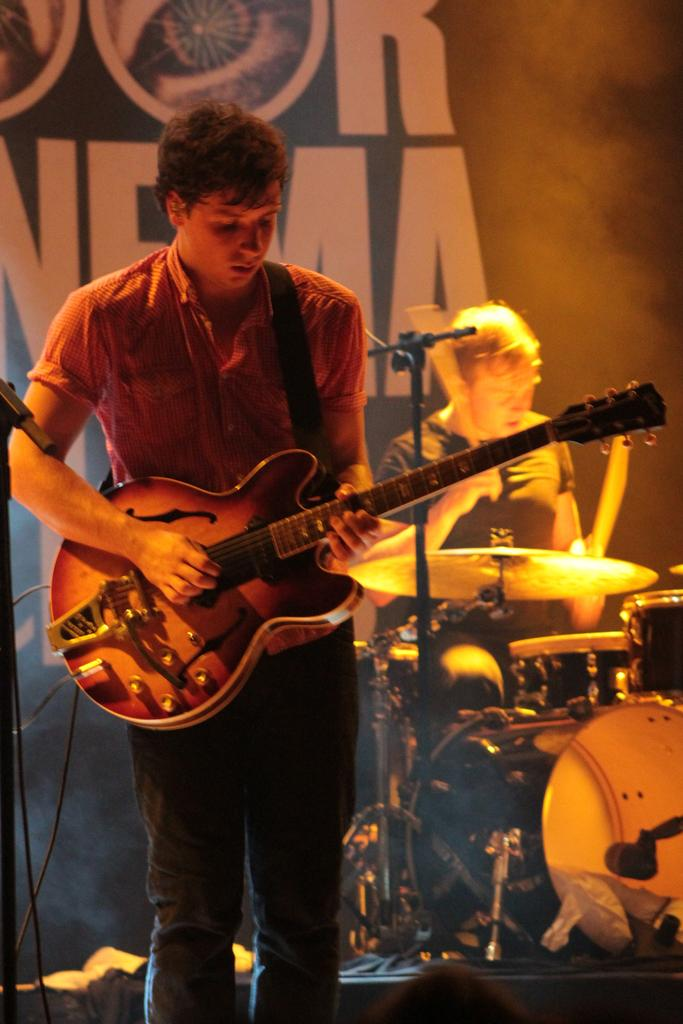What is the main subject of the image? The main subject of the image is a man. What is the man wearing in the image? The man is wearing a shirt in the image. What is the man doing in the image? The man is playing a guitar in the image. Can you describe the person far from the man in the image? The person far from the man is holding sticks and playing musical instruments. How many cherries can be seen on the man's shirt in the image? There are no cherries visible on the man's shirt in the image. What type of plane is flying in the background of the image? There is no plane visible in the background of the image. 